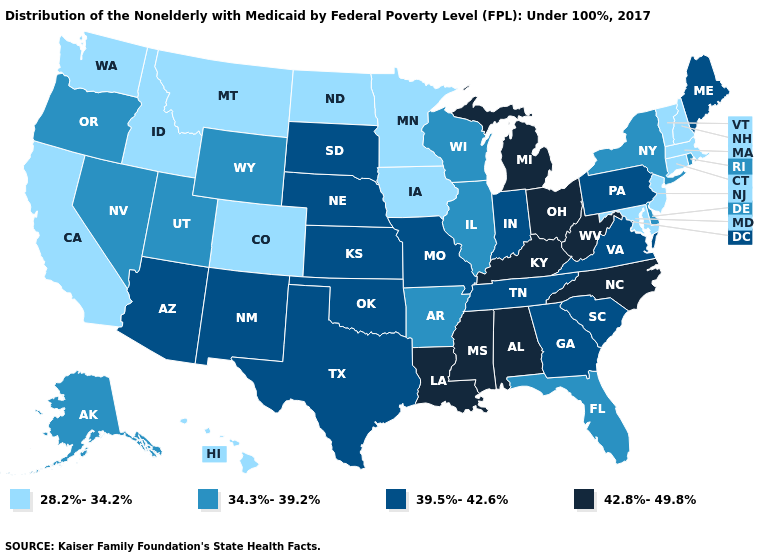Does Oklahoma have a lower value than Idaho?
Write a very short answer. No. Does Oregon have the lowest value in the West?
Write a very short answer. No. Name the states that have a value in the range 28.2%-34.2%?
Be succinct. California, Colorado, Connecticut, Hawaii, Idaho, Iowa, Maryland, Massachusetts, Minnesota, Montana, New Hampshire, New Jersey, North Dakota, Vermont, Washington. Does the first symbol in the legend represent the smallest category?
Concise answer only. Yes. Does Maryland have the lowest value in the South?
Keep it brief. Yes. Does Kentucky have the highest value in the South?
Answer briefly. Yes. What is the value of Montana?
Keep it brief. 28.2%-34.2%. Does the map have missing data?
Concise answer only. No. What is the value of Pennsylvania?
Quick response, please. 39.5%-42.6%. What is the value of Utah?
Quick response, please. 34.3%-39.2%. What is the highest value in the MidWest ?
Keep it brief. 42.8%-49.8%. How many symbols are there in the legend?
Quick response, please. 4. Does Texas have the highest value in the USA?
Quick response, please. No. Does the map have missing data?
Quick response, please. No. Name the states that have a value in the range 34.3%-39.2%?
Concise answer only. Alaska, Arkansas, Delaware, Florida, Illinois, Nevada, New York, Oregon, Rhode Island, Utah, Wisconsin, Wyoming. 